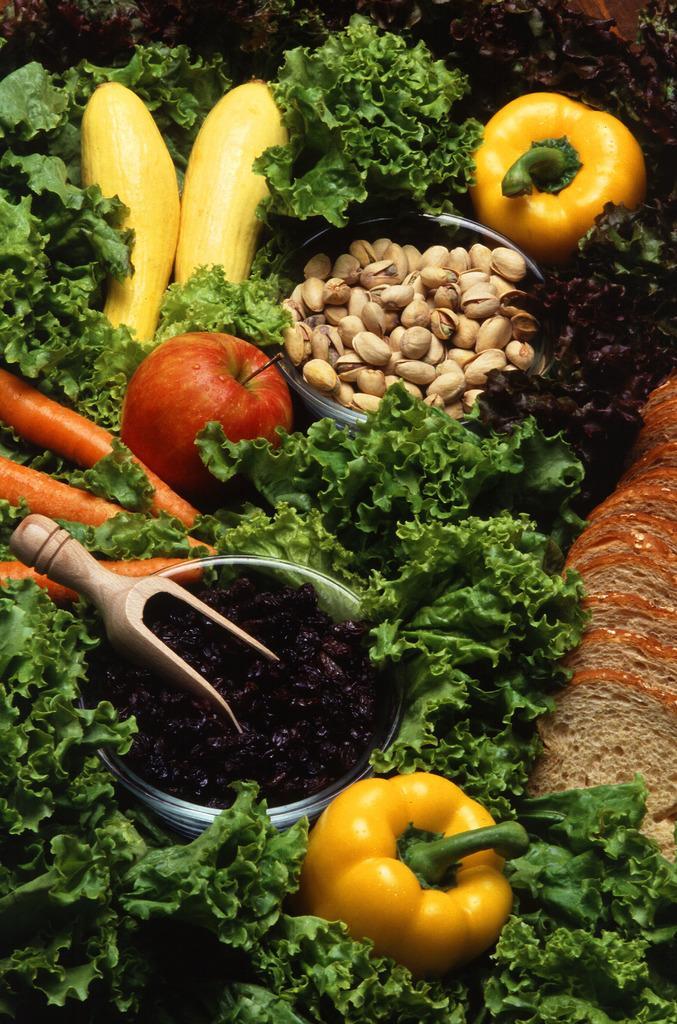Describe this image in one or two sentences. In this image there are vegetables like capsicum,carrot and an apple. In the middle there are beetroot pieces in the glass bowl. In the bowl there is a wooden spoon. On the right side there are pista seeds in the bowl. 